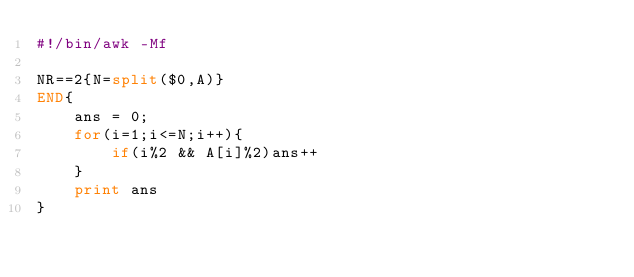<code> <loc_0><loc_0><loc_500><loc_500><_Awk_>#!/bin/awk -Mf

NR==2{N=split($0,A)}
END{
    ans = 0;
    for(i=1;i<=N;i++){
        if(i%2 && A[i]%2)ans++
    }
    print ans
}
</code> 